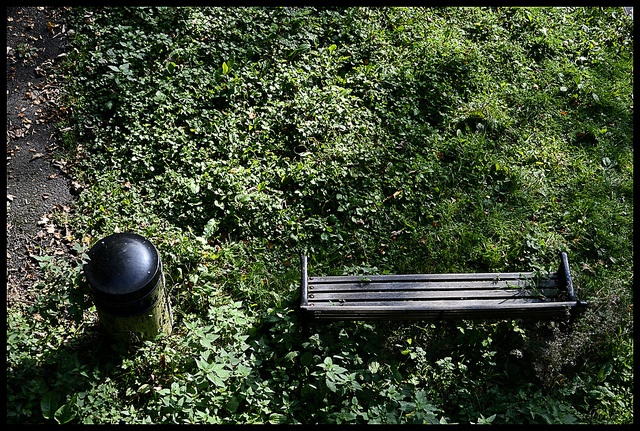Describe the objects in this image and their specific colors. I can see a bench in black, darkgray, gray, and lightgray tones in this image. 